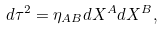Convert formula to latex. <formula><loc_0><loc_0><loc_500><loc_500>d \tau ^ { 2 } = \eta _ { A B } d X ^ { A } d X ^ { B } ,</formula> 